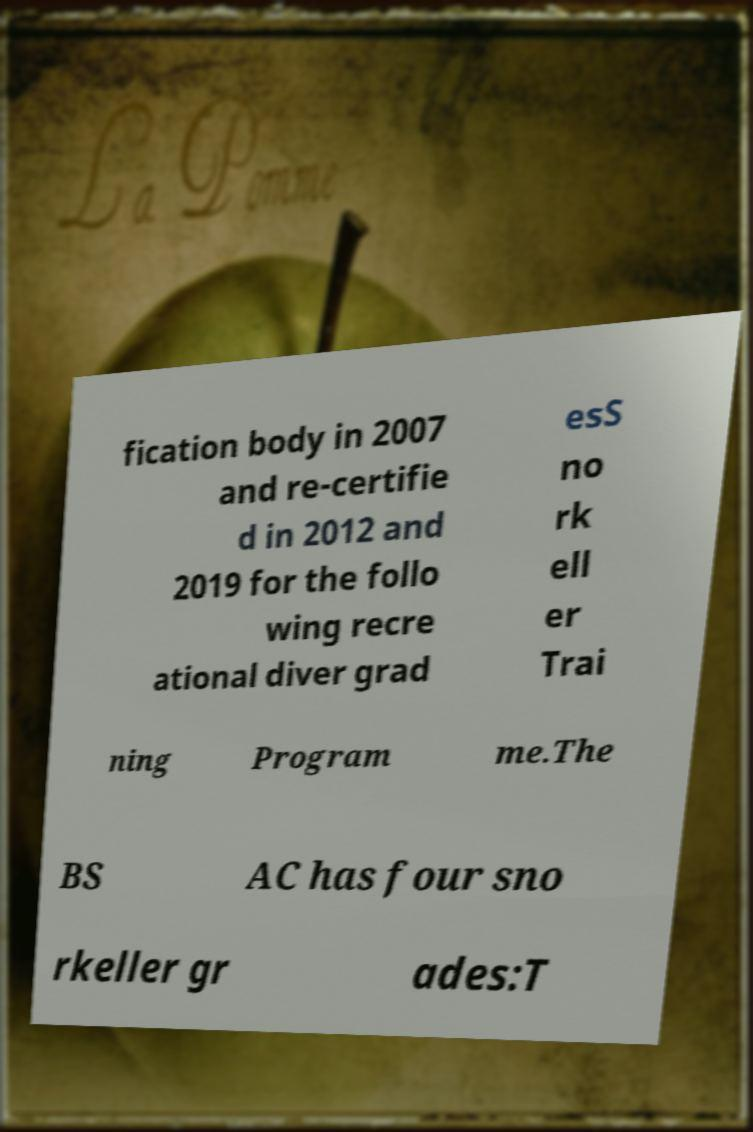Please identify and transcribe the text found in this image. fication body in 2007 and re-certifie d in 2012 and 2019 for the follo wing recre ational diver grad esS no rk ell er Trai ning Program me.The BS AC has four sno rkeller gr ades:T 